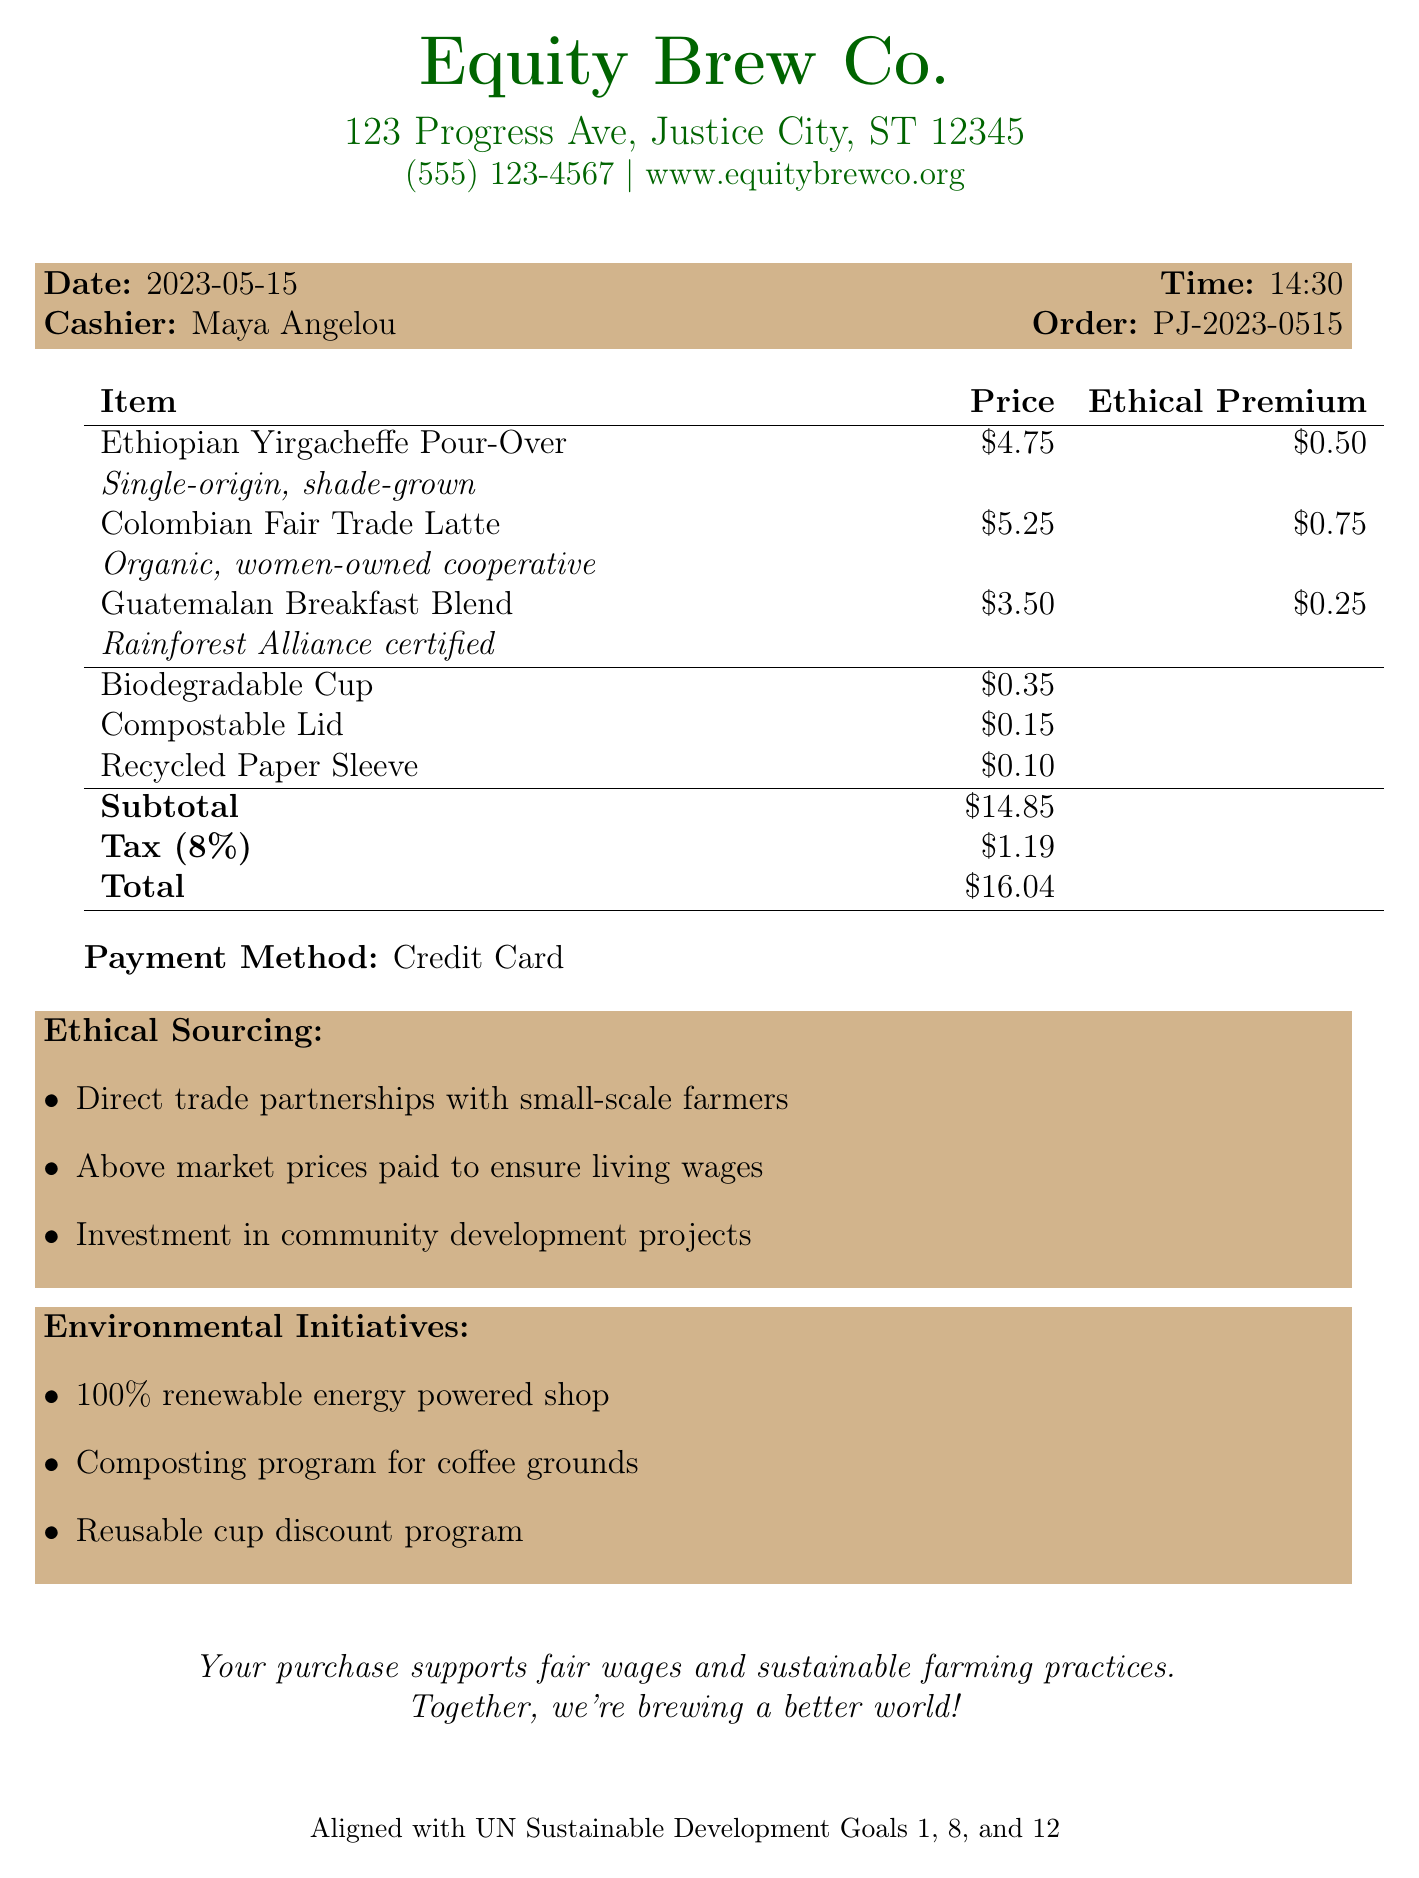What is the name of the coffee shop? The name of the coffee shop is displayed prominently at the top of the document as "Equity Brew Co."
Answer: Equity Brew Co What is the date of the receipt? The date is indicated in the document under the receipt details, listed as "2023-05-15."
Answer: 2023-05-15 Who was the cashier for this order? The cashier's name is provided next to the cashier label in the document, which is "Maya Angelou."
Answer: Maya Angelou What is the total price of the order? The total price is calculated and shown at the bottom of the itemized list, reading "$16.04."
Answer: $16.04 How much is the ethical premium for the Colombian Fair Trade Latte? The ethical premium is noted next to the item, specifically for the Colombian Fair Trade Latte, which is "$0.75."
Answer: $0.75 What percentage of tax was applied to the order? The tax is specified in the receipt details as "8%."
Answer: 8% What initiatives does the coffee shop support regarding environmental practices? The document lists several initiatives, including "100% renewable energy powered shop," among others, under environmental initiatives.
Answer: 100% renewable energy powered shop How does the shop ensure fair trading practices? The ethical sourcing section mentions direct trade and above-market prices to ensure living wages.
Answer: Direct trade partnerships with small-scale farmers What is the social impact message noted on the receipt? A message promoting social impact is provided at the bottom, stating how purchases contribute to social initiatives.
Answer: Your purchase supports fair wages and sustainable farming practices. Together, we're brewing a better world! 